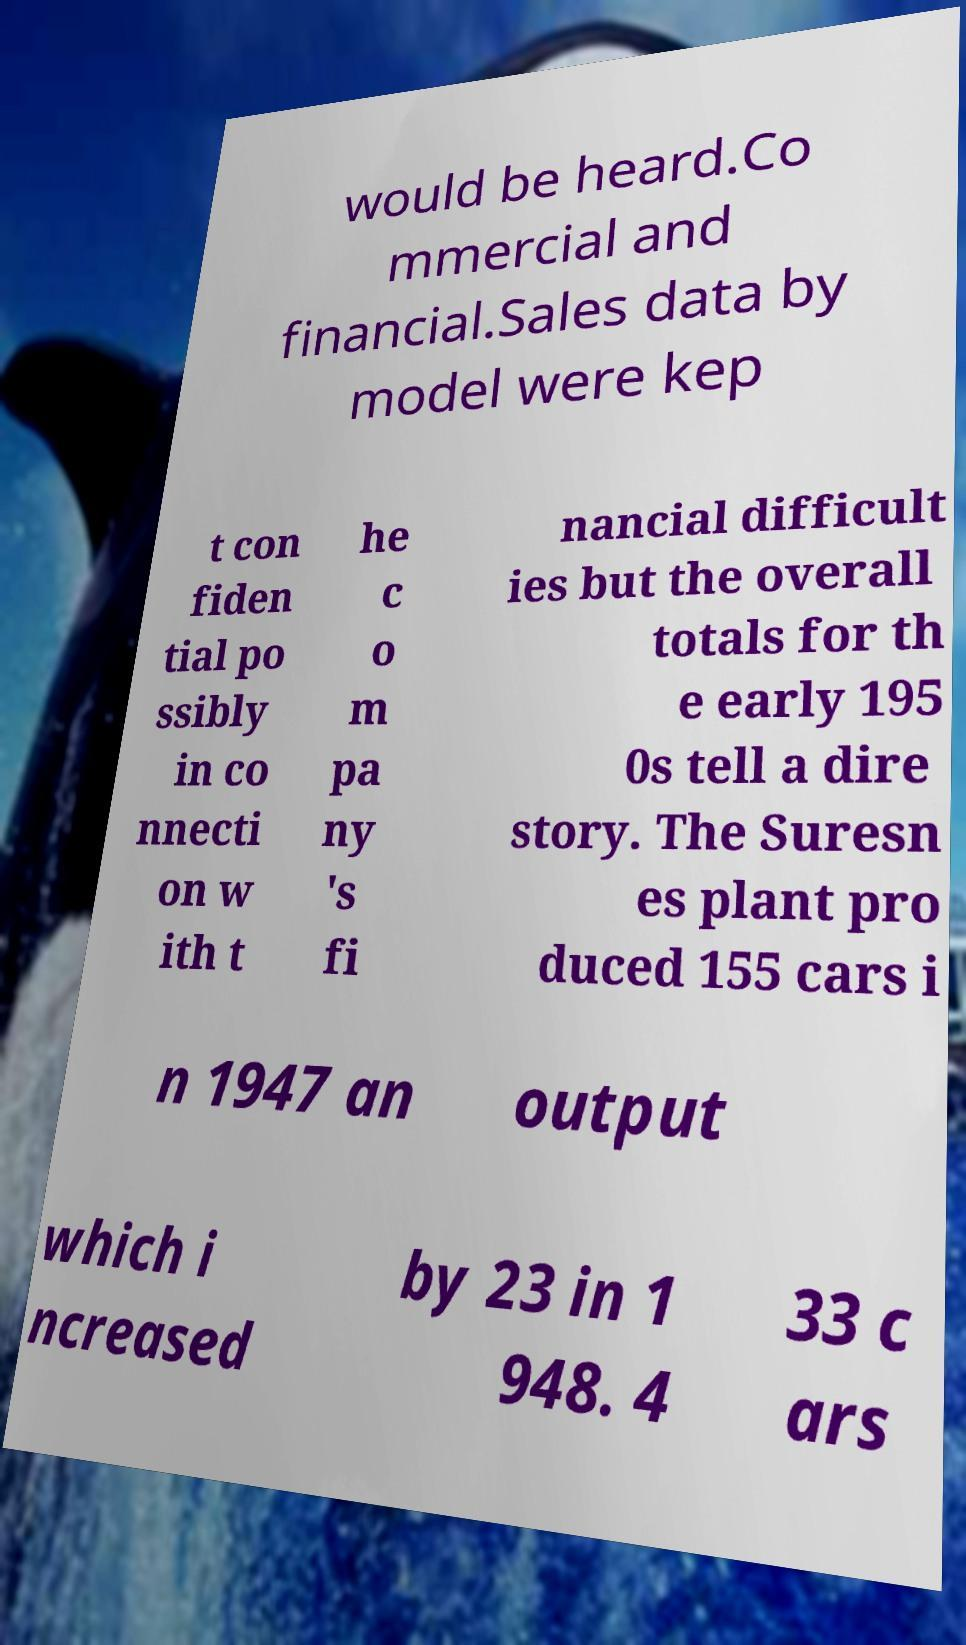Please identify and transcribe the text found in this image. would be heard.Co mmercial and financial.Sales data by model were kep t con fiden tial po ssibly in co nnecti on w ith t he c o m pa ny 's fi nancial difficult ies but the overall totals for th e early 195 0s tell a dire story. The Suresn es plant pro duced 155 cars i n 1947 an output which i ncreased by 23 in 1 948. 4 33 c ars 